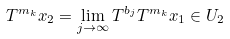Convert formula to latex. <formula><loc_0><loc_0><loc_500><loc_500>T ^ { m _ { k } } x _ { 2 } = \lim _ { j \to \infty } T ^ { b _ { j } } T ^ { m _ { k } } x _ { 1 } \in U _ { 2 }</formula> 